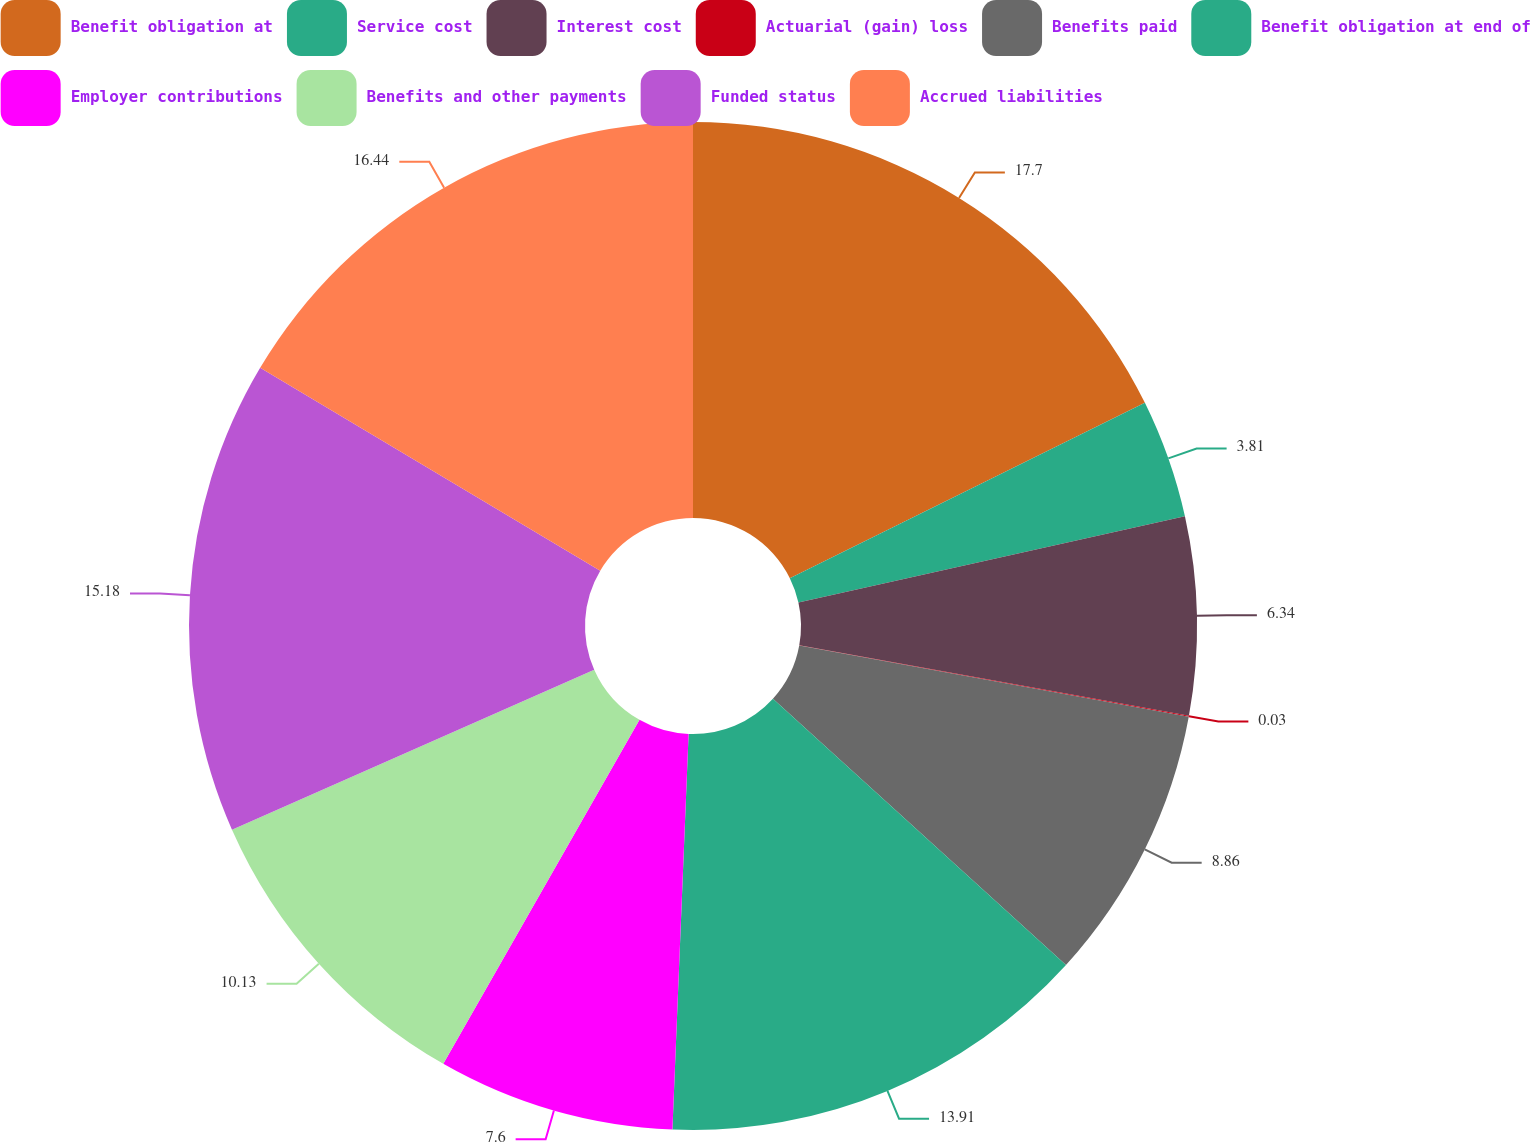Convert chart. <chart><loc_0><loc_0><loc_500><loc_500><pie_chart><fcel>Benefit obligation at<fcel>Service cost<fcel>Interest cost<fcel>Actuarial (gain) loss<fcel>Benefits paid<fcel>Benefit obligation at end of<fcel>Employer contributions<fcel>Benefits and other payments<fcel>Funded status<fcel>Accrued liabilities<nl><fcel>17.7%<fcel>3.81%<fcel>6.34%<fcel>0.03%<fcel>8.86%<fcel>13.91%<fcel>7.6%<fcel>10.13%<fcel>15.18%<fcel>16.44%<nl></chart> 